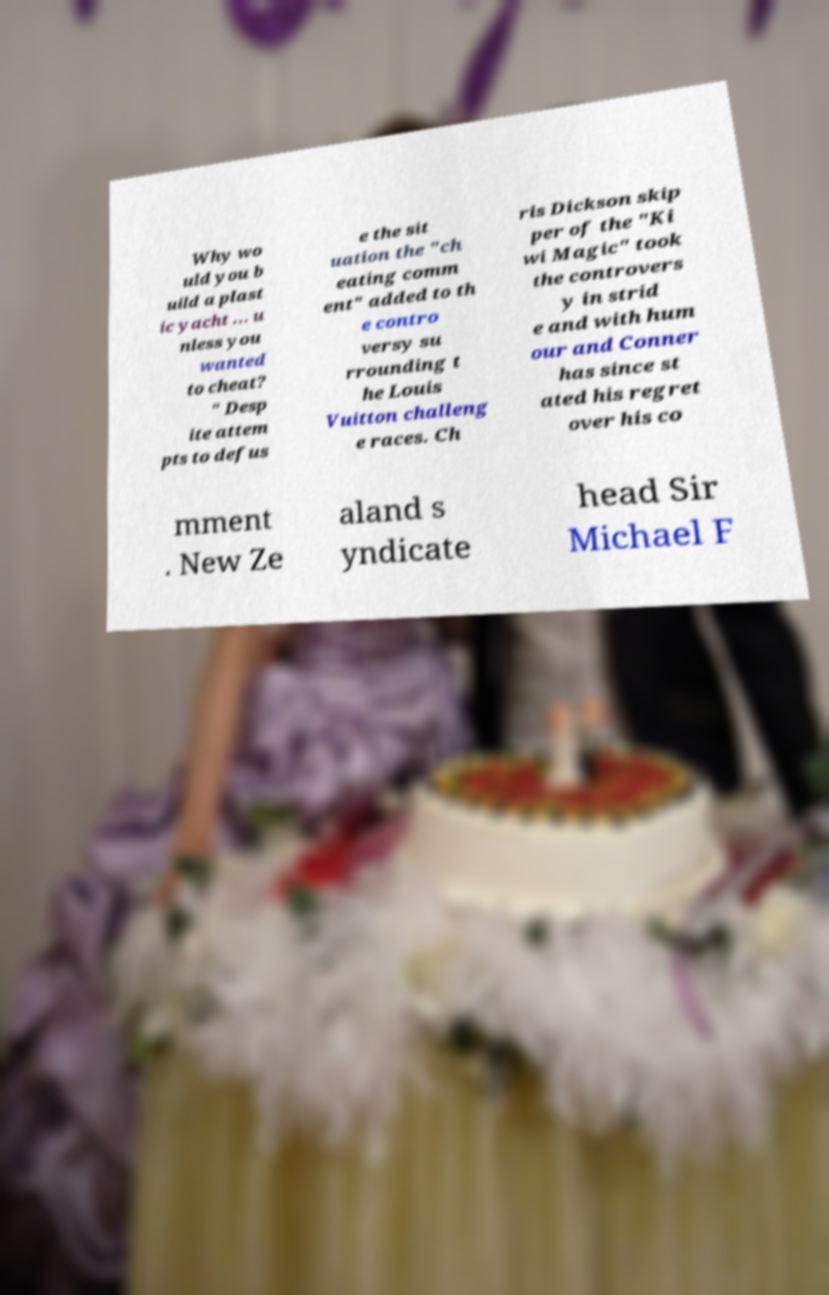For documentation purposes, I need the text within this image transcribed. Could you provide that? Why wo uld you b uild a plast ic yacht ... u nless you wanted to cheat? " Desp ite attem pts to defus e the sit uation the "ch eating comm ent" added to th e contro versy su rrounding t he Louis Vuitton challeng e races. Ch ris Dickson skip per of the "Ki wi Magic" took the controvers y in strid e and with hum our and Conner has since st ated his regret over his co mment . New Ze aland s yndicate head Sir Michael F 